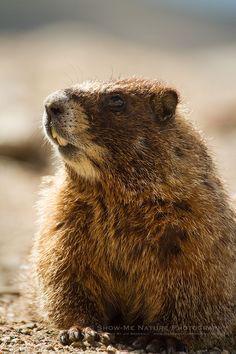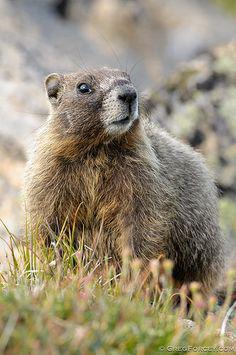The first image is the image on the left, the second image is the image on the right. Given the left and right images, does the statement "In one image the prairie dog is eating food that it is holding in its paws." hold true? Answer yes or no. No. 